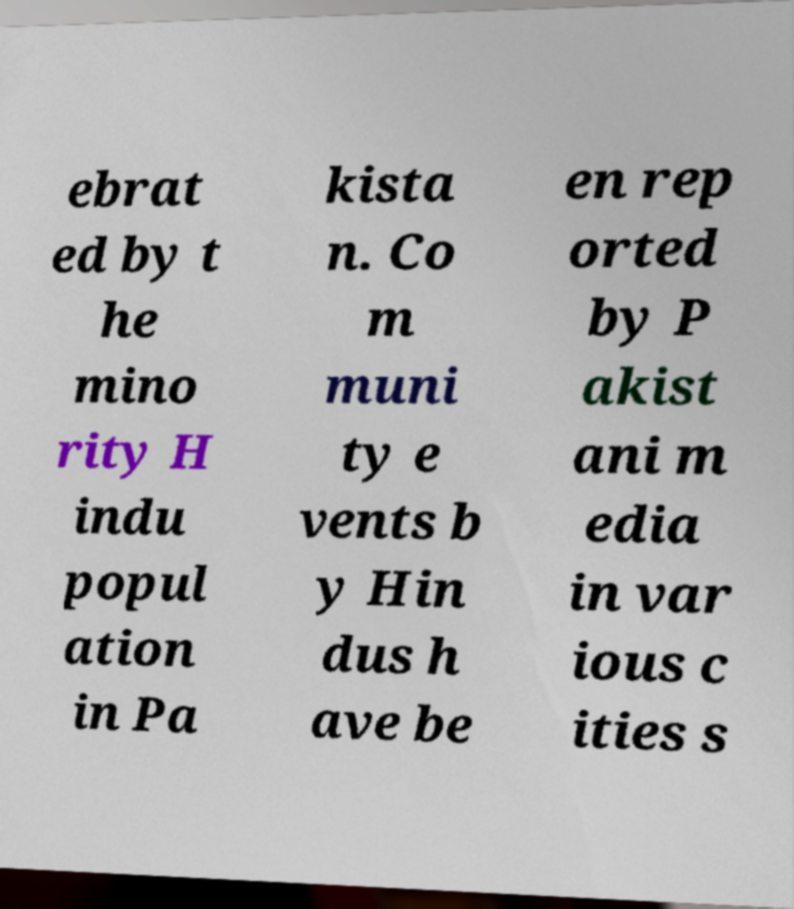I need the written content from this picture converted into text. Can you do that? ebrat ed by t he mino rity H indu popul ation in Pa kista n. Co m muni ty e vents b y Hin dus h ave be en rep orted by P akist ani m edia in var ious c ities s 